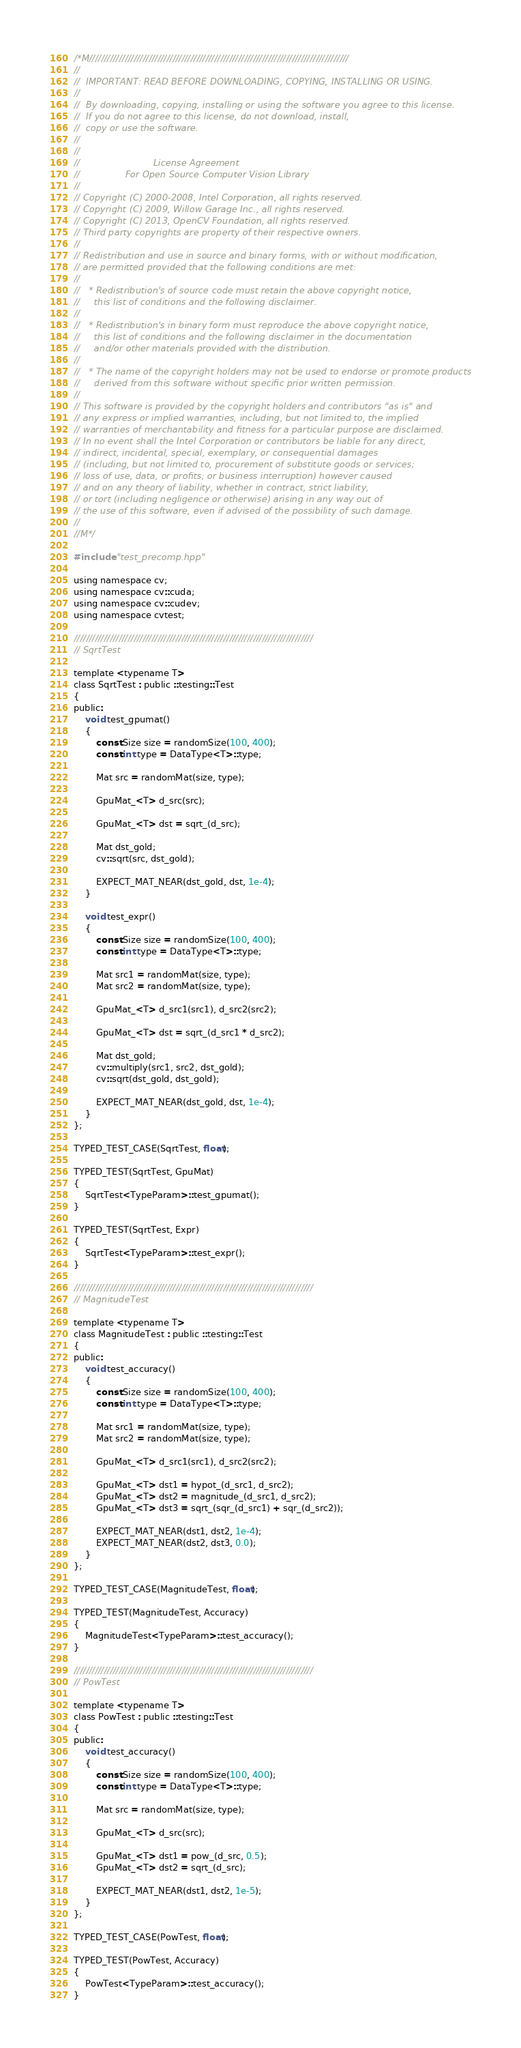Convert code to text. <code><loc_0><loc_0><loc_500><loc_500><_Cuda_>/*M///////////////////////////////////////////////////////////////////////////////////////
//
//  IMPORTANT: READ BEFORE DOWNLOADING, COPYING, INSTALLING OR USING.
//
//  By downloading, copying, installing or using the software you agree to this license.
//  If you do not agree to this license, do not download, install,
//  copy or use the software.
//
//
//                          License Agreement
//                For Open Source Computer Vision Library
//
// Copyright (C) 2000-2008, Intel Corporation, all rights reserved.
// Copyright (C) 2009, Willow Garage Inc., all rights reserved.
// Copyright (C) 2013, OpenCV Foundation, all rights reserved.
// Third party copyrights are property of their respective owners.
//
// Redistribution and use in source and binary forms, with or without modification,
// are permitted provided that the following conditions are met:
//
//   * Redistribution's of source code must retain the above copyright notice,
//     this list of conditions and the following disclaimer.
//
//   * Redistribution's in binary form must reproduce the above copyright notice,
//     this list of conditions and the following disclaimer in the documentation
//     and/or other materials provided with the distribution.
//
//   * The name of the copyright holders may not be used to endorse or promote products
//     derived from this software without specific prior written permission.
//
// This software is provided by the copyright holders and contributors "as is" and
// any express or implied warranties, including, but not limited to, the implied
// warranties of merchantability and fitness for a particular purpose are disclaimed.
// In no event shall the Intel Corporation or contributors be liable for any direct,
// indirect, incidental, special, exemplary, or consequential damages
// (including, but not limited to, procurement of substitute goods or services;
// loss of use, data, or profits; or business interruption) however caused
// and on any theory of liability, whether in contract, strict liability,
// or tort (including negligence or otherwise) arising in any way out of
// the use of this software, even if advised of the possibility of such damage.
//
//M*/

#include "test_precomp.hpp"

using namespace cv;
using namespace cv::cuda;
using namespace cv::cudev;
using namespace cvtest;

////////////////////////////////////////////////////////////////////////////////
// SqrtTest

template <typename T>
class SqrtTest : public ::testing::Test
{
public:
    void test_gpumat()
    {
        const Size size = randomSize(100, 400);
        const int type = DataType<T>::type;

        Mat src = randomMat(size, type);

        GpuMat_<T> d_src(src);

        GpuMat_<T> dst = sqrt_(d_src);

        Mat dst_gold;
        cv::sqrt(src, dst_gold);

        EXPECT_MAT_NEAR(dst_gold, dst, 1e-4);
    }

    void test_expr()
    {
        const Size size = randomSize(100, 400);
        const int type = DataType<T>::type;

        Mat src1 = randomMat(size, type);
        Mat src2 = randomMat(size, type);

        GpuMat_<T> d_src1(src1), d_src2(src2);

        GpuMat_<T> dst = sqrt_(d_src1 * d_src2);

        Mat dst_gold;
        cv::multiply(src1, src2, dst_gold);
        cv::sqrt(dst_gold, dst_gold);

        EXPECT_MAT_NEAR(dst_gold, dst, 1e-4);
    }
};

TYPED_TEST_CASE(SqrtTest, float);

TYPED_TEST(SqrtTest, GpuMat)
{
    SqrtTest<TypeParam>::test_gpumat();
}

TYPED_TEST(SqrtTest, Expr)
{
    SqrtTest<TypeParam>::test_expr();
}

////////////////////////////////////////////////////////////////////////////////
// MagnitudeTest

template <typename T>
class MagnitudeTest : public ::testing::Test
{
public:
    void test_accuracy()
    {
        const Size size = randomSize(100, 400);
        const int type = DataType<T>::type;

        Mat src1 = randomMat(size, type);
        Mat src2 = randomMat(size, type);

        GpuMat_<T> d_src1(src1), d_src2(src2);

        GpuMat_<T> dst1 = hypot_(d_src1, d_src2);
        GpuMat_<T> dst2 = magnitude_(d_src1, d_src2);
        GpuMat_<T> dst3 = sqrt_(sqr_(d_src1) + sqr_(d_src2));

        EXPECT_MAT_NEAR(dst1, dst2, 1e-4);
        EXPECT_MAT_NEAR(dst2, dst3, 0.0);
    }
};

TYPED_TEST_CASE(MagnitudeTest, float);

TYPED_TEST(MagnitudeTest, Accuracy)
{
    MagnitudeTest<TypeParam>::test_accuracy();
}

////////////////////////////////////////////////////////////////////////////////
// PowTest

template <typename T>
class PowTest : public ::testing::Test
{
public:
    void test_accuracy()
    {
        const Size size = randomSize(100, 400);
        const int type = DataType<T>::type;

        Mat src = randomMat(size, type);

        GpuMat_<T> d_src(src);

        GpuMat_<T> dst1 = pow_(d_src, 0.5);
        GpuMat_<T> dst2 = sqrt_(d_src);

        EXPECT_MAT_NEAR(dst1, dst2, 1e-5);
    }
};

TYPED_TEST_CASE(PowTest, float);

TYPED_TEST(PowTest, Accuracy)
{
    PowTest<TypeParam>::test_accuracy();
}
</code> 